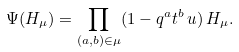Convert formula to latex. <formula><loc_0><loc_0><loc_500><loc_500>\Psi ( H _ { \mu } ) = \prod _ { ( a , b ) \in \mu } ( 1 - q ^ { a } t ^ { b } \, u ) \, H _ { \mu } .</formula> 